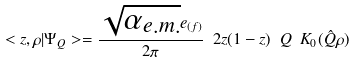Convert formula to latex. <formula><loc_0><loc_0><loc_500><loc_500>< z , \rho | \Psi _ { Q } > = \frac { \sqrt { \alpha _ { e . m . } } e _ { ( f ) } } { 2 \pi } \ 2 z ( 1 - z ) \ Q \ K _ { 0 } ( \hat { Q } \rho )</formula> 